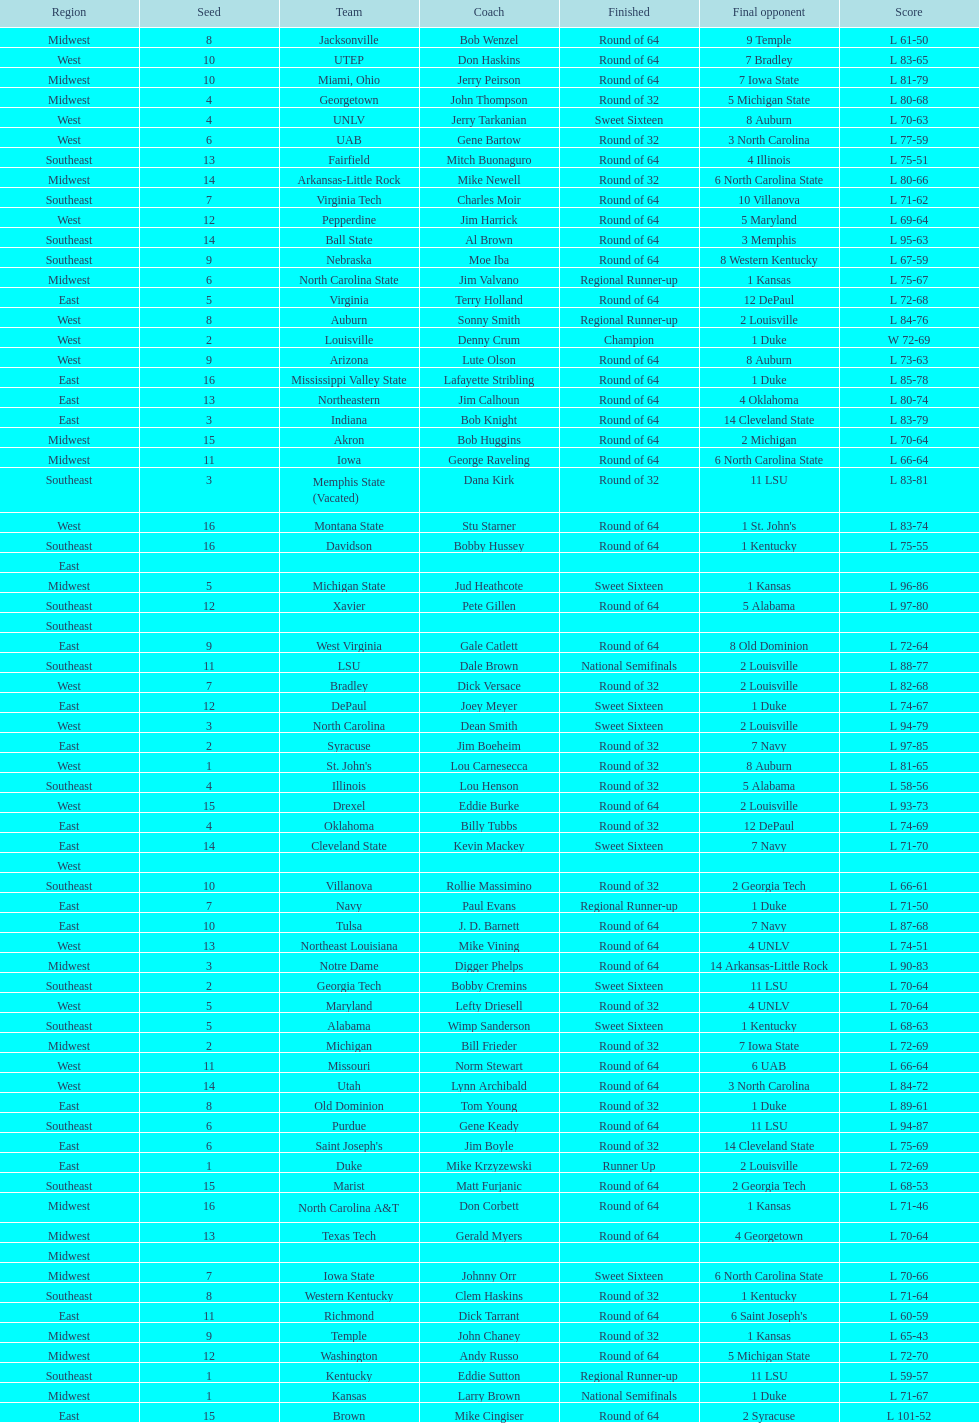How many number of teams played altogether? 64. 